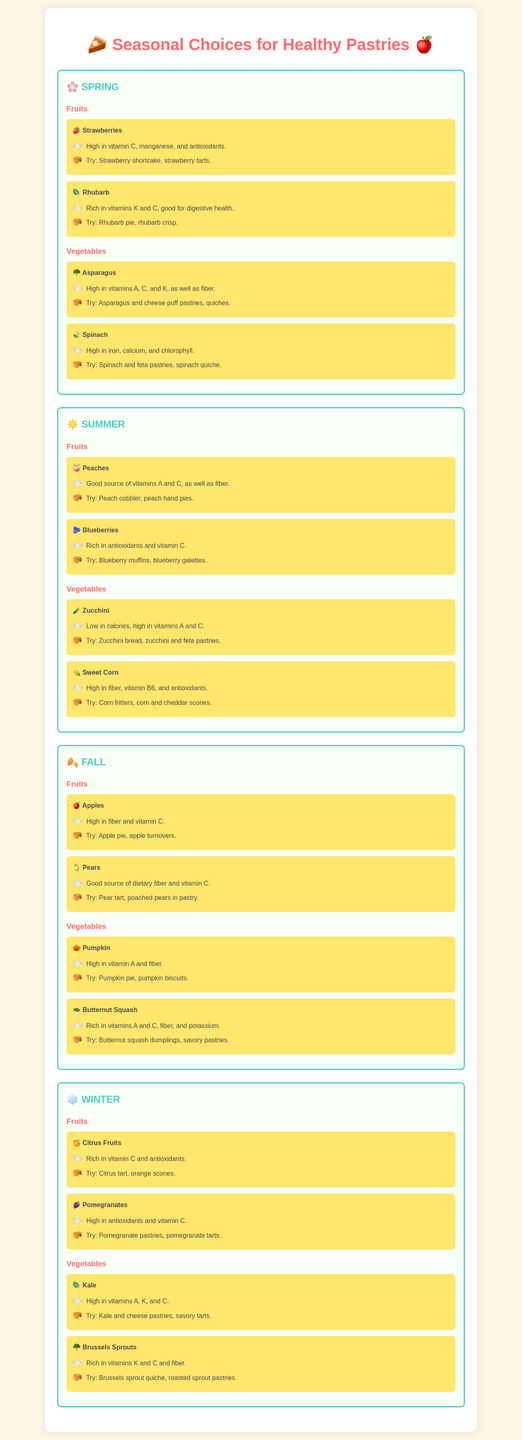What fruits are available in Spring? The document lists strawberries and rhubarb as fruits available in Spring.
Answer: Strawberries, Rhubarb What is one pastry you can make with blueberries? The document states to try blueberry muffins as a pastry option with blueberries.
Answer: Blueberry muffins Which vegetable in Fall is high in vitamin A and fiber? The document mentions pumpkin as a vegetable that is high in vitamin A and fiber.
Answer: Pumpkin What are the main nutrients found in spinach? The document highlights that spinach is high in iron, calcium, and chlorophyll.
Answer: Iron, Calcium, Chlorophyll What seasonal fillings can you find in Winter? The document identifies citrus fruits and pomegranates as seasonal fruits in Winter.
Answer: Citrus Fruits, Pomegranates Which season features peaches? The document shows that peaches are available in Summer.
Answer: Summer What type of filling can you use for a pastry in Fall that is high in fiber? The document mentions apples which are high in fiber.
Answer: Apples What is a suggested pastry to make with sweet corn? The document lists corn fritters as a suggested pastry with sweet corn.
Answer: Corn fritters Which season includes zucchini? The document states that zucchini is found in Summer.
Answer: Summer 